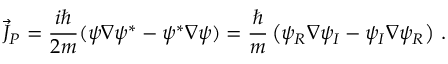Convert formula to latex. <formula><loc_0><loc_0><loc_500><loc_500>\vec { J } _ { P } = \frac { i } { 2 m } ( \psi \nabla \psi ^ { * } - \psi ^ { * } \nabla \psi ) = \frac { } { m } \left ( \psi _ { R } \nabla \psi _ { I } - \psi _ { I } \nabla \psi _ { R } \right ) \, .</formula> 